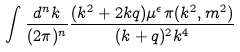Convert formula to latex. <formula><loc_0><loc_0><loc_500><loc_500>\int \frac { d ^ { n } k } { ( 2 \pi ) ^ { n } } \frac { ( k ^ { 2 } + 2 k q ) \mu ^ { \epsilon } \pi ( k ^ { 2 } , m ^ { 2 } ) } { ( k + q ) ^ { 2 } k ^ { 4 } }</formula> 